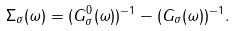<formula> <loc_0><loc_0><loc_500><loc_500>\Sigma _ { \sigma } ( \omega ) = ( G _ { \sigma } ^ { 0 } ( \omega ) ) ^ { - 1 } - ( G _ { \sigma } ( \omega ) ) ^ { - 1 } .</formula> 